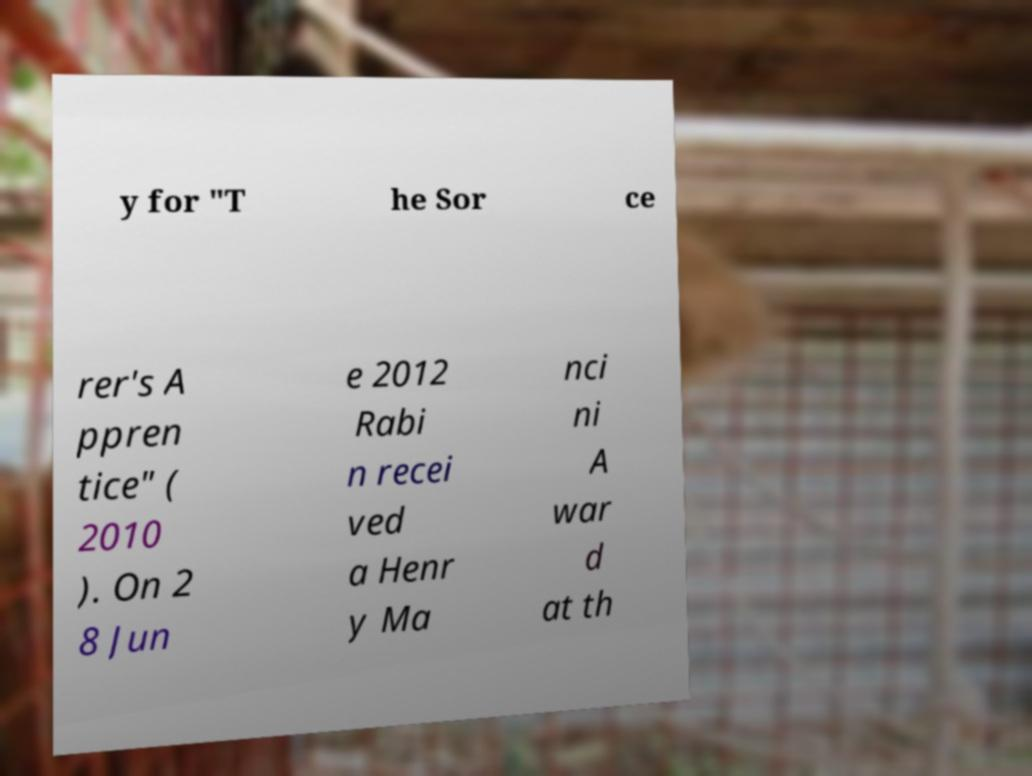Please identify and transcribe the text found in this image. y for "T he Sor ce rer's A ppren tice" ( 2010 ). On 2 8 Jun e 2012 Rabi n recei ved a Henr y Ma nci ni A war d at th 